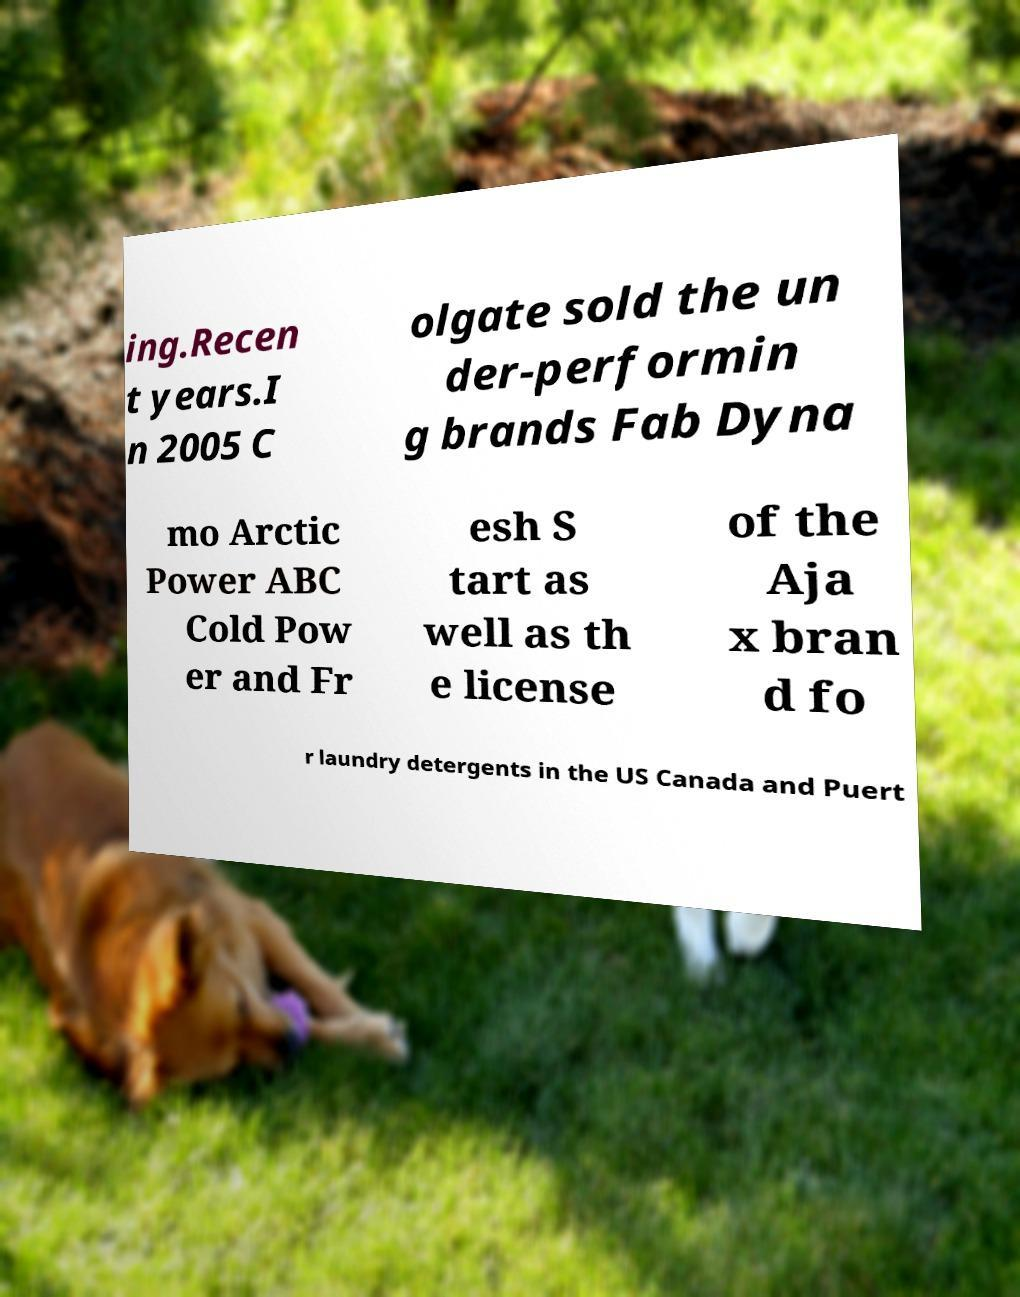Can you read and provide the text displayed in the image?This photo seems to have some interesting text. Can you extract and type it out for me? ing.Recen t years.I n 2005 C olgate sold the un der-performin g brands Fab Dyna mo Arctic Power ABC Cold Pow er and Fr esh S tart as well as th e license of the Aja x bran d fo r laundry detergents in the US Canada and Puert 